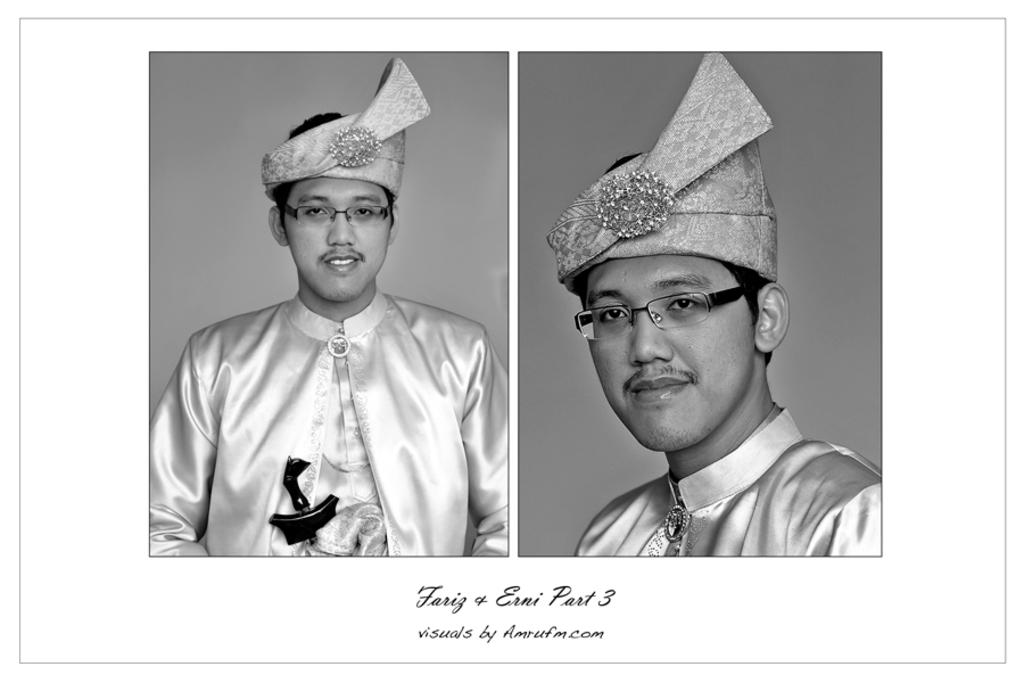What is the composition of the image? The image is a collage of two pictures. Can you describe the attire of the person in the image? The person in the image is wearing a cap. What color scheme is used in the image? The image is in black and white color. What type of music is being played in the background of the image? There is no music present in the image, as it is a still collage of two pictures. Can you see an ant crawling on the person's cap in the image? There is no ant visible in the image; the person is wearing a cap, but no insects are present. 